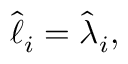Convert formula to latex. <formula><loc_0><loc_0><loc_500><loc_500>\begin{array} { r } { \hat { \ell } _ { i } = \hat { \lambda } _ { i } , } \end{array}</formula> 